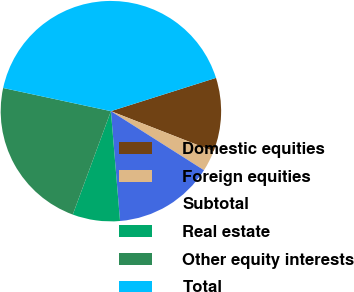Convert chart. <chart><loc_0><loc_0><loc_500><loc_500><pie_chart><fcel>Domestic equities<fcel>Foreign equities<fcel>Subtotal<fcel>Real estate<fcel>Other equity interests<fcel>Total<nl><fcel>10.81%<fcel>3.07%<fcel>14.68%<fcel>6.94%<fcel>22.75%<fcel>41.75%<nl></chart> 